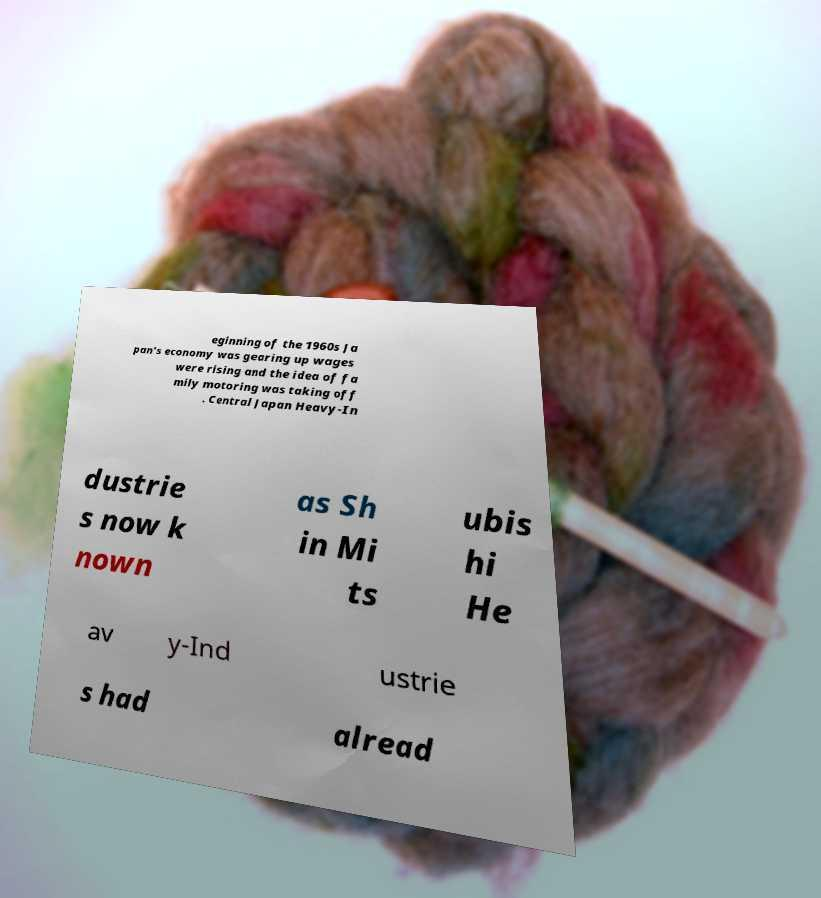Could you assist in decoding the text presented in this image and type it out clearly? eginning of the 1960s Ja pan's economy was gearing up wages were rising and the idea of fa mily motoring was taking off . Central Japan Heavy-In dustrie s now k nown as Sh in Mi ts ubis hi He av y-Ind ustrie s had alread 